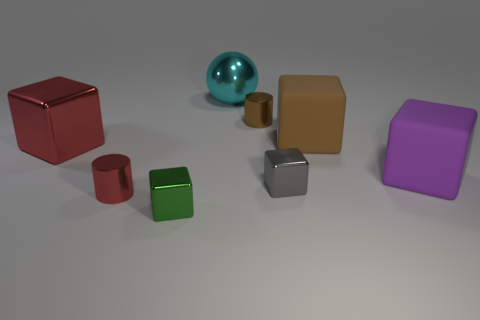Do the brown object to the left of the big brown object and the large metallic object in front of the brown rubber object have the same shape?
Your answer should be compact. No. There is a large shiny thing right of the cylinder to the left of the brown cylinder; what color is it?
Ensure brevity in your answer.  Cyan. How many cylinders are small red metallic objects or big brown rubber things?
Ensure brevity in your answer.  1. How many small metallic things are in front of the metallic cylinder that is behind the tiny cylinder that is on the left side of the tiny brown cylinder?
Ensure brevity in your answer.  3. What is the size of the shiny cylinder that is the same color as the big shiny cube?
Your answer should be very brief. Small. Are there any tiny green objects that have the same material as the brown cylinder?
Offer a terse response. Yes. Are the big purple object and the brown cube made of the same material?
Make the answer very short. Yes. There is a cylinder on the left side of the small green object; how many gray shiny objects are in front of it?
Make the answer very short. 0. What number of blue objects are tiny metallic cylinders or large matte blocks?
Keep it short and to the point. 0. There is a red metal object behind the large matte object that is right of the big matte object that is left of the big purple rubber object; what shape is it?
Give a very brief answer. Cube. 